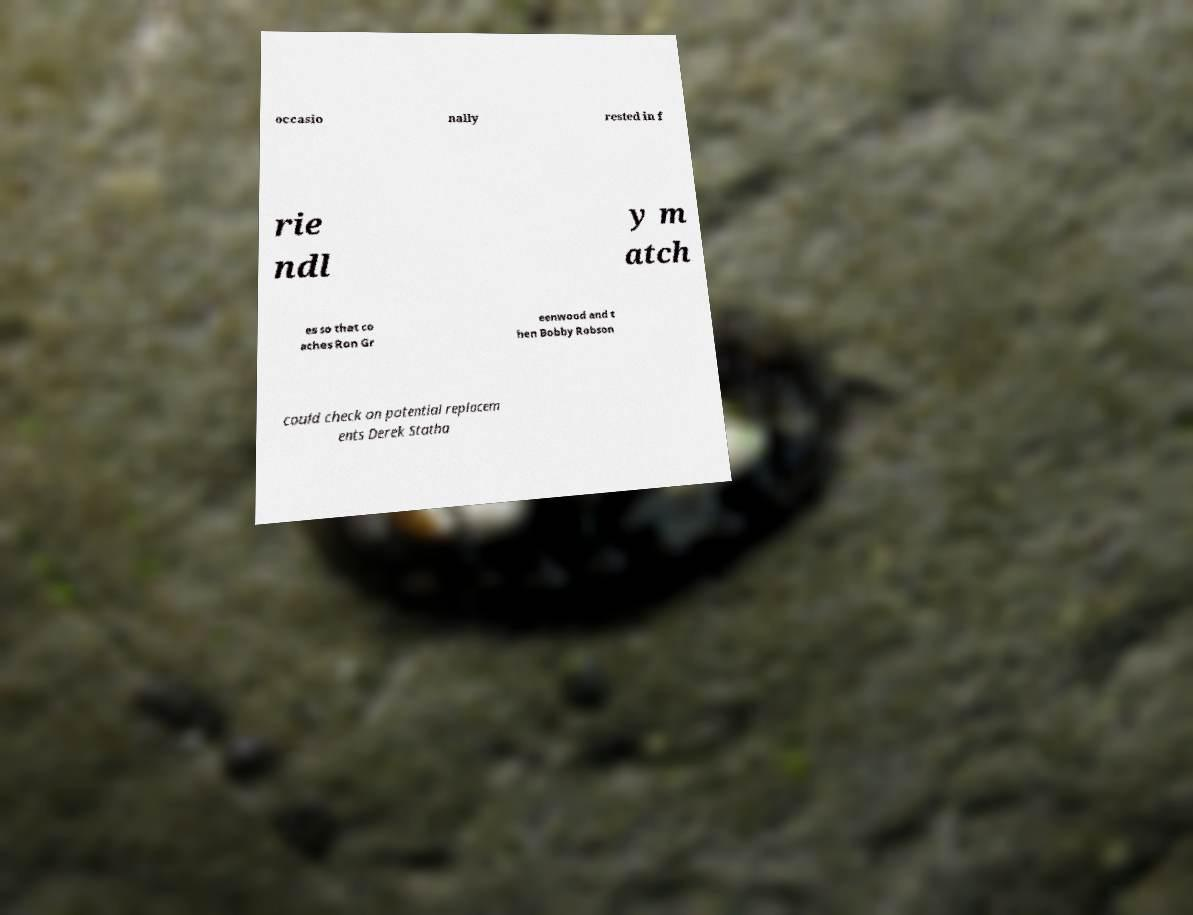I need the written content from this picture converted into text. Can you do that? occasio nally rested in f rie ndl y m atch es so that co aches Ron Gr eenwood and t hen Bobby Robson could check on potential replacem ents Derek Statha 